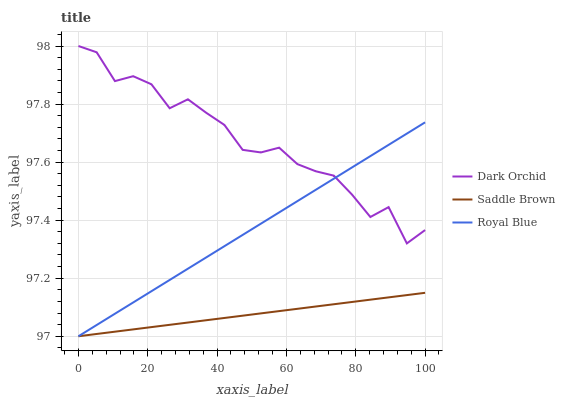Does Saddle Brown have the minimum area under the curve?
Answer yes or no. Yes. Does Dark Orchid have the maximum area under the curve?
Answer yes or no. Yes. Does Dark Orchid have the minimum area under the curve?
Answer yes or no. No. Does Saddle Brown have the maximum area under the curve?
Answer yes or no. No. Is Royal Blue the smoothest?
Answer yes or no. Yes. Is Dark Orchid the roughest?
Answer yes or no. Yes. Is Saddle Brown the smoothest?
Answer yes or no. No. Is Saddle Brown the roughest?
Answer yes or no. No. Does Royal Blue have the lowest value?
Answer yes or no. Yes. Does Dark Orchid have the lowest value?
Answer yes or no. No. Does Dark Orchid have the highest value?
Answer yes or no. Yes. Does Saddle Brown have the highest value?
Answer yes or no. No. Is Saddle Brown less than Dark Orchid?
Answer yes or no. Yes. Is Dark Orchid greater than Saddle Brown?
Answer yes or no. Yes. Does Royal Blue intersect Dark Orchid?
Answer yes or no. Yes. Is Royal Blue less than Dark Orchid?
Answer yes or no. No. Is Royal Blue greater than Dark Orchid?
Answer yes or no. No. Does Saddle Brown intersect Dark Orchid?
Answer yes or no. No. 